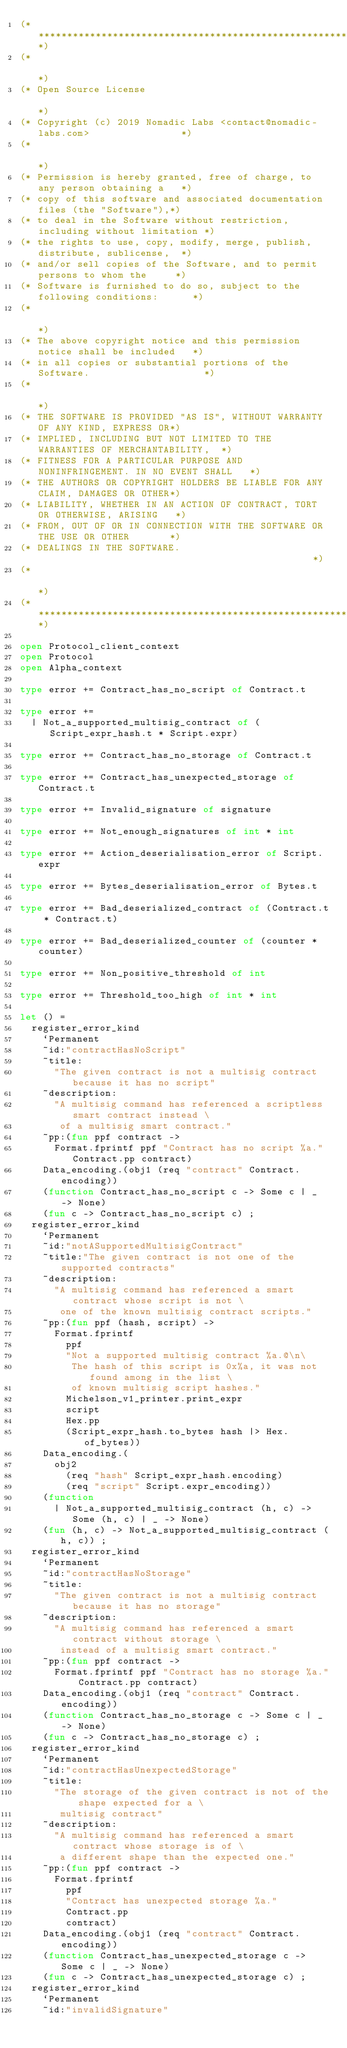Convert code to text. <code><loc_0><loc_0><loc_500><loc_500><_OCaml_>(*****************************************************************************)
(*                                                                           *)
(* Open Source License                                                       *)
(* Copyright (c) 2019 Nomadic Labs <contact@nomadic-labs.com>                *)
(*                                                                           *)
(* Permission is hereby granted, free of charge, to any person obtaining a   *)
(* copy of this software and associated documentation files (the "Software"),*)
(* to deal in the Software without restriction, including without limitation *)
(* the rights to use, copy, modify, merge, publish, distribute, sublicense,  *)
(* and/or sell copies of the Software, and to permit persons to whom the     *)
(* Software is furnished to do so, subject to the following conditions:      *)
(*                                                                           *)
(* The above copyright notice and this permission notice shall be included   *)
(* in all copies or substantial portions of the Software.                    *)
(*                                                                           *)
(* THE SOFTWARE IS PROVIDED "AS IS", WITHOUT WARRANTY OF ANY KIND, EXPRESS OR*)
(* IMPLIED, INCLUDING BUT NOT LIMITED TO THE WARRANTIES OF MERCHANTABILITY,  *)
(* FITNESS FOR A PARTICULAR PURPOSE AND NONINFRINGEMENT. IN NO EVENT SHALL   *)
(* THE AUTHORS OR COPYRIGHT HOLDERS BE LIABLE FOR ANY CLAIM, DAMAGES OR OTHER*)
(* LIABILITY, WHETHER IN AN ACTION OF CONTRACT, TORT OR OTHERWISE, ARISING   *)
(* FROM, OUT OF OR IN CONNECTION WITH THE SOFTWARE OR THE USE OR OTHER       *)
(* DEALINGS IN THE SOFTWARE.                                                 *)
(*                                                                           *)
(*****************************************************************************)

open Protocol_client_context
open Protocol
open Alpha_context

type error += Contract_has_no_script of Contract.t

type error +=
  | Not_a_supported_multisig_contract of (Script_expr_hash.t * Script.expr)

type error += Contract_has_no_storage of Contract.t

type error += Contract_has_unexpected_storage of Contract.t

type error += Invalid_signature of signature

type error += Not_enough_signatures of int * int

type error += Action_deserialisation_error of Script.expr

type error += Bytes_deserialisation_error of Bytes.t

type error += Bad_deserialized_contract of (Contract.t * Contract.t)

type error += Bad_deserialized_counter of (counter * counter)

type error += Non_positive_threshold of int

type error += Threshold_too_high of int * int

let () =
  register_error_kind
    `Permanent
    ~id:"contractHasNoScript"
    ~title:
      "The given contract is not a multisig contract because it has no script"
    ~description:
      "A multisig command has referenced a scriptless smart contract instead \
       of a multisig smart contract."
    ~pp:(fun ppf contract ->
      Format.fprintf ppf "Contract has no script %a." Contract.pp contract)
    Data_encoding.(obj1 (req "contract" Contract.encoding))
    (function Contract_has_no_script c -> Some c | _ -> None)
    (fun c -> Contract_has_no_script c) ;
  register_error_kind
    `Permanent
    ~id:"notASupportedMultisigContract"
    ~title:"The given contract is not one of the supported contracts"
    ~description:
      "A multisig command has referenced a smart contract whose script is not \
       one of the known multisig contract scripts."
    ~pp:(fun ppf (hash, script) ->
      Format.fprintf
        ppf
        "Not a supported multisig contract %a.@\n\
         The hash of this script is 0x%a, it was not found among in the list \
         of known multisig script hashes."
        Michelson_v1_printer.print_expr
        script
        Hex.pp
        (Script_expr_hash.to_bytes hash |> Hex.of_bytes))
    Data_encoding.(
      obj2
        (req "hash" Script_expr_hash.encoding)
        (req "script" Script.expr_encoding))
    (function
      | Not_a_supported_multisig_contract (h, c) -> Some (h, c) | _ -> None)
    (fun (h, c) -> Not_a_supported_multisig_contract (h, c)) ;
  register_error_kind
    `Permanent
    ~id:"contractHasNoStorage"
    ~title:
      "The given contract is not a multisig contract because it has no storage"
    ~description:
      "A multisig command has referenced a smart contract without storage \
       instead of a multisig smart contract."
    ~pp:(fun ppf contract ->
      Format.fprintf ppf "Contract has no storage %a." Contract.pp contract)
    Data_encoding.(obj1 (req "contract" Contract.encoding))
    (function Contract_has_no_storage c -> Some c | _ -> None)
    (fun c -> Contract_has_no_storage c) ;
  register_error_kind
    `Permanent
    ~id:"contractHasUnexpectedStorage"
    ~title:
      "The storage of the given contract is not of the shape expected for a \
       multisig contract"
    ~description:
      "A multisig command has referenced a smart contract whose storage is of \
       a different shape than the expected one."
    ~pp:(fun ppf contract ->
      Format.fprintf
        ppf
        "Contract has unexpected storage %a."
        Contract.pp
        contract)
    Data_encoding.(obj1 (req "contract" Contract.encoding))
    (function Contract_has_unexpected_storage c -> Some c | _ -> None)
    (fun c -> Contract_has_unexpected_storage c) ;
  register_error_kind
    `Permanent
    ~id:"invalidSignature"</code> 